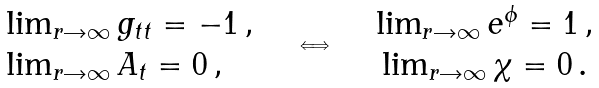Convert formula to latex. <formula><loc_0><loc_0><loc_500><loc_500>\begin{array} { l } \lim _ { r \rightarrow \infty } g _ { t t } = - 1 \, , \\ \lim _ { r \rightarrow \infty } A _ { t } = 0 \, , \end{array} \quad \Longleftrightarrow \quad \begin{array} { c } \lim _ { r \rightarrow \infty } e ^ { \phi } = 1 \, , \\ \lim _ { r \rightarrow \infty } \chi = 0 \, . \end{array}</formula> 